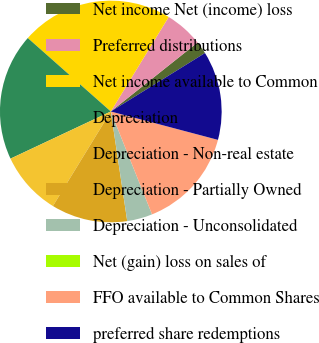<chart> <loc_0><loc_0><loc_500><loc_500><pie_chart><fcel>Net income Net (income) loss<fcel>Preferred distributions<fcel>Net income available to Common<fcel>Depreciation<fcel>Depreciation - Non-real estate<fcel>Depreciation - Partially Owned<fcel>Depreciation - Unconsolidated<fcel>Net (gain) loss on sales of<fcel>FFO available to Common Shares<fcel>preferred share redemptions<nl><fcel>1.85%<fcel>5.56%<fcel>22.22%<fcel>18.52%<fcel>9.26%<fcel>11.11%<fcel>3.7%<fcel>0.0%<fcel>14.81%<fcel>12.96%<nl></chart> 